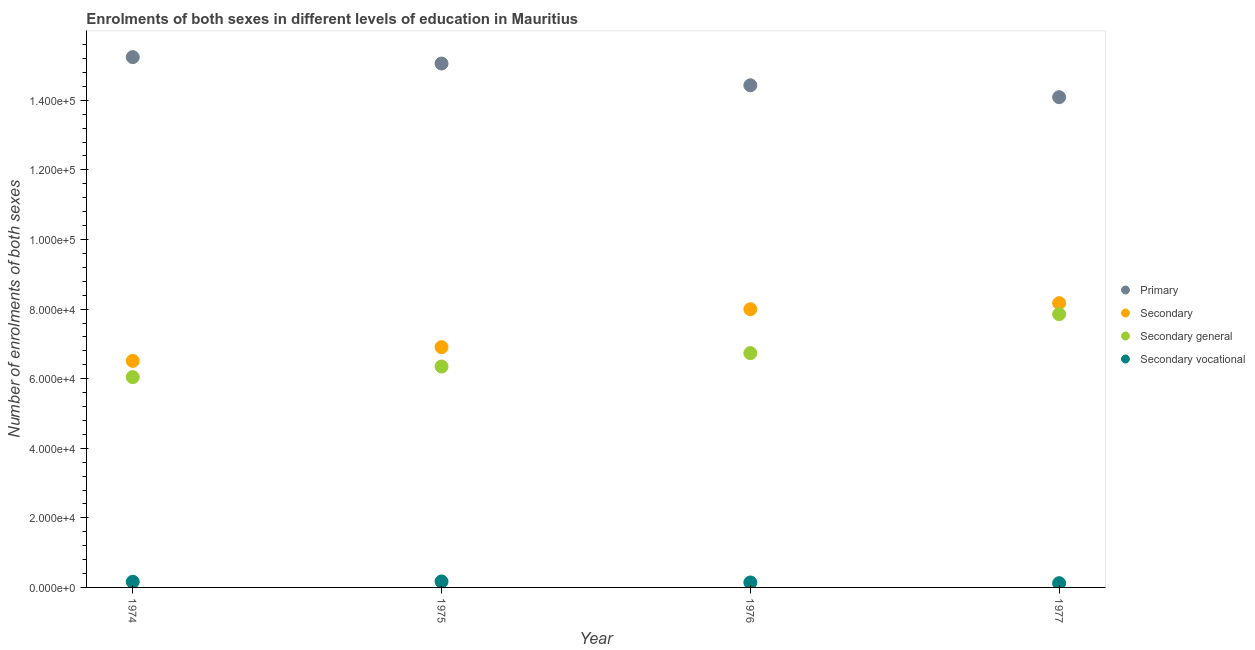What is the number of enrolments in secondary education in 1977?
Keep it short and to the point. 8.17e+04. Across all years, what is the maximum number of enrolments in secondary vocational education?
Make the answer very short. 1716. Across all years, what is the minimum number of enrolments in primary education?
Ensure brevity in your answer.  1.41e+05. In which year was the number of enrolments in primary education maximum?
Offer a very short reply. 1974. In which year was the number of enrolments in secondary general education minimum?
Your response must be concise. 1974. What is the total number of enrolments in secondary education in the graph?
Offer a very short reply. 2.96e+05. What is the difference between the number of enrolments in secondary education in 1974 and that in 1976?
Offer a very short reply. -1.48e+04. What is the difference between the number of enrolments in secondary general education in 1974 and the number of enrolments in secondary education in 1976?
Provide a short and direct response. -1.95e+04. What is the average number of enrolments in secondary vocational education per year?
Provide a succinct answer. 1495.25. In the year 1976, what is the difference between the number of enrolments in secondary general education and number of enrolments in secondary education?
Your answer should be compact. -1.26e+04. In how many years, is the number of enrolments in primary education greater than 124000?
Your answer should be very brief. 4. What is the ratio of the number of enrolments in primary education in 1976 to that in 1977?
Your response must be concise. 1.02. What is the difference between the highest and the second highest number of enrolments in secondary general education?
Your answer should be very brief. 1.12e+04. What is the difference between the highest and the lowest number of enrolments in primary education?
Your response must be concise. 1.15e+04. Is it the case that in every year, the sum of the number of enrolments in primary education and number of enrolments in secondary education is greater than the number of enrolments in secondary general education?
Your answer should be very brief. Yes. Does the number of enrolments in secondary general education monotonically increase over the years?
Provide a short and direct response. Yes. Does the graph contain any zero values?
Your answer should be very brief. No. Where does the legend appear in the graph?
Your answer should be very brief. Center right. What is the title of the graph?
Give a very brief answer. Enrolments of both sexes in different levels of education in Mauritius. What is the label or title of the Y-axis?
Offer a very short reply. Number of enrolments of both sexes. What is the Number of enrolments of both sexes of Primary in 1974?
Give a very brief answer. 1.52e+05. What is the Number of enrolments of both sexes of Secondary in 1974?
Offer a terse response. 6.51e+04. What is the Number of enrolments of both sexes of Secondary general in 1974?
Offer a terse response. 6.04e+04. What is the Number of enrolments of both sexes of Secondary vocational in 1974?
Make the answer very short. 1621. What is the Number of enrolments of both sexes in Primary in 1975?
Offer a very short reply. 1.51e+05. What is the Number of enrolments of both sexes of Secondary in 1975?
Offer a terse response. 6.91e+04. What is the Number of enrolments of both sexes of Secondary general in 1975?
Provide a succinct answer. 6.35e+04. What is the Number of enrolments of both sexes in Secondary vocational in 1975?
Make the answer very short. 1716. What is the Number of enrolments of both sexes of Primary in 1976?
Make the answer very short. 1.44e+05. What is the Number of enrolments of both sexes of Secondary in 1976?
Keep it short and to the point. 8.00e+04. What is the Number of enrolments of both sexes in Secondary general in 1976?
Provide a short and direct response. 6.73e+04. What is the Number of enrolments of both sexes of Secondary vocational in 1976?
Your response must be concise. 1423. What is the Number of enrolments of both sexes in Primary in 1977?
Keep it short and to the point. 1.41e+05. What is the Number of enrolments of both sexes in Secondary in 1977?
Your answer should be very brief. 8.17e+04. What is the Number of enrolments of both sexes of Secondary general in 1977?
Provide a short and direct response. 7.85e+04. What is the Number of enrolments of both sexes of Secondary vocational in 1977?
Keep it short and to the point. 1221. Across all years, what is the maximum Number of enrolments of both sexes of Primary?
Provide a succinct answer. 1.52e+05. Across all years, what is the maximum Number of enrolments of both sexes in Secondary?
Provide a succinct answer. 8.17e+04. Across all years, what is the maximum Number of enrolments of both sexes in Secondary general?
Your answer should be very brief. 7.85e+04. Across all years, what is the maximum Number of enrolments of both sexes in Secondary vocational?
Keep it short and to the point. 1716. Across all years, what is the minimum Number of enrolments of both sexes of Primary?
Your answer should be very brief. 1.41e+05. Across all years, what is the minimum Number of enrolments of both sexes in Secondary?
Provide a short and direct response. 6.51e+04. Across all years, what is the minimum Number of enrolments of both sexes in Secondary general?
Give a very brief answer. 6.04e+04. Across all years, what is the minimum Number of enrolments of both sexes of Secondary vocational?
Your answer should be compact. 1221. What is the total Number of enrolments of both sexes of Primary in the graph?
Your answer should be very brief. 5.88e+05. What is the total Number of enrolments of both sexes in Secondary in the graph?
Provide a succinct answer. 2.96e+05. What is the total Number of enrolments of both sexes of Secondary general in the graph?
Keep it short and to the point. 2.70e+05. What is the total Number of enrolments of both sexes in Secondary vocational in the graph?
Give a very brief answer. 5981. What is the difference between the Number of enrolments of both sexes of Primary in 1974 and that in 1975?
Your response must be concise. 1844. What is the difference between the Number of enrolments of both sexes in Secondary in 1974 and that in 1975?
Keep it short and to the point. -3948. What is the difference between the Number of enrolments of both sexes of Secondary general in 1974 and that in 1975?
Ensure brevity in your answer.  -3051. What is the difference between the Number of enrolments of both sexes of Secondary vocational in 1974 and that in 1975?
Offer a very short reply. -95. What is the difference between the Number of enrolments of both sexes of Primary in 1974 and that in 1976?
Offer a terse response. 8092. What is the difference between the Number of enrolments of both sexes in Secondary in 1974 and that in 1976?
Offer a very short reply. -1.48e+04. What is the difference between the Number of enrolments of both sexes in Secondary general in 1974 and that in 1976?
Your answer should be compact. -6904. What is the difference between the Number of enrolments of both sexes of Secondary vocational in 1974 and that in 1976?
Offer a very short reply. 198. What is the difference between the Number of enrolments of both sexes in Primary in 1974 and that in 1977?
Your response must be concise. 1.15e+04. What is the difference between the Number of enrolments of both sexes in Secondary in 1974 and that in 1977?
Offer a very short reply. -1.66e+04. What is the difference between the Number of enrolments of both sexes in Secondary general in 1974 and that in 1977?
Ensure brevity in your answer.  -1.81e+04. What is the difference between the Number of enrolments of both sexes in Secondary vocational in 1974 and that in 1977?
Make the answer very short. 400. What is the difference between the Number of enrolments of both sexes of Primary in 1975 and that in 1976?
Offer a very short reply. 6248. What is the difference between the Number of enrolments of both sexes in Secondary in 1975 and that in 1976?
Ensure brevity in your answer.  -1.09e+04. What is the difference between the Number of enrolments of both sexes of Secondary general in 1975 and that in 1976?
Your answer should be very brief. -3853. What is the difference between the Number of enrolments of both sexes in Secondary vocational in 1975 and that in 1976?
Provide a short and direct response. 293. What is the difference between the Number of enrolments of both sexes of Primary in 1975 and that in 1977?
Provide a short and direct response. 9668. What is the difference between the Number of enrolments of both sexes in Secondary in 1975 and that in 1977?
Keep it short and to the point. -1.26e+04. What is the difference between the Number of enrolments of both sexes of Secondary general in 1975 and that in 1977?
Provide a succinct answer. -1.50e+04. What is the difference between the Number of enrolments of both sexes in Secondary vocational in 1975 and that in 1977?
Give a very brief answer. 495. What is the difference between the Number of enrolments of both sexes in Primary in 1976 and that in 1977?
Make the answer very short. 3420. What is the difference between the Number of enrolments of both sexes in Secondary in 1976 and that in 1977?
Provide a short and direct response. -1739. What is the difference between the Number of enrolments of both sexes of Secondary general in 1976 and that in 1977?
Provide a succinct answer. -1.12e+04. What is the difference between the Number of enrolments of both sexes of Secondary vocational in 1976 and that in 1977?
Offer a very short reply. 202. What is the difference between the Number of enrolments of both sexes of Primary in 1974 and the Number of enrolments of both sexes of Secondary in 1975?
Offer a terse response. 8.34e+04. What is the difference between the Number of enrolments of both sexes of Primary in 1974 and the Number of enrolments of both sexes of Secondary general in 1975?
Provide a succinct answer. 8.89e+04. What is the difference between the Number of enrolments of both sexes in Primary in 1974 and the Number of enrolments of both sexes in Secondary vocational in 1975?
Ensure brevity in your answer.  1.51e+05. What is the difference between the Number of enrolments of both sexes of Secondary in 1974 and the Number of enrolments of both sexes of Secondary general in 1975?
Provide a succinct answer. 1621. What is the difference between the Number of enrolments of both sexes of Secondary in 1974 and the Number of enrolments of both sexes of Secondary vocational in 1975?
Provide a short and direct response. 6.34e+04. What is the difference between the Number of enrolments of both sexes in Secondary general in 1974 and the Number of enrolments of both sexes in Secondary vocational in 1975?
Provide a short and direct response. 5.87e+04. What is the difference between the Number of enrolments of both sexes of Primary in 1974 and the Number of enrolments of both sexes of Secondary in 1976?
Provide a succinct answer. 7.25e+04. What is the difference between the Number of enrolments of both sexes of Primary in 1974 and the Number of enrolments of both sexes of Secondary general in 1976?
Offer a terse response. 8.51e+04. What is the difference between the Number of enrolments of both sexes of Primary in 1974 and the Number of enrolments of both sexes of Secondary vocational in 1976?
Keep it short and to the point. 1.51e+05. What is the difference between the Number of enrolments of both sexes of Secondary in 1974 and the Number of enrolments of both sexes of Secondary general in 1976?
Give a very brief answer. -2232. What is the difference between the Number of enrolments of both sexes in Secondary in 1974 and the Number of enrolments of both sexes in Secondary vocational in 1976?
Offer a terse response. 6.37e+04. What is the difference between the Number of enrolments of both sexes in Secondary general in 1974 and the Number of enrolments of both sexes in Secondary vocational in 1976?
Keep it short and to the point. 5.90e+04. What is the difference between the Number of enrolments of both sexes in Primary in 1974 and the Number of enrolments of both sexes in Secondary in 1977?
Make the answer very short. 7.07e+04. What is the difference between the Number of enrolments of both sexes in Primary in 1974 and the Number of enrolments of both sexes in Secondary general in 1977?
Your response must be concise. 7.39e+04. What is the difference between the Number of enrolments of both sexes of Primary in 1974 and the Number of enrolments of both sexes of Secondary vocational in 1977?
Ensure brevity in your answer.  1.51e+05. What is the difference between the Number of enrolments of both sexes of Secondary in 1974 and the Number of enrolments of both sexes of Secondary general in 1977?
Keep it short and to the point. -1.34e+04. What is the difference between the Number of enrolments of both sexes of Secondary in 1974 and the Number of enrolments of both sexes of Secondary vocational in 1977?
Provide a short and direct response. 6.39e+04. What is the difference between the Number of enrolments of both sexes of Secondary general in 1974 and the Number of enrolments of both sexes of Secondary vocational in 1977?
Provide a short and direct response. 5.92e+04. What is the difference between the Number of enrolments of both sexes of Primary in 1975 and the Number of enrolments of both sexes of Secondary in 1976?
Provide a short and direct response. 7.06e+04. What is the difference between the Number of enrolments of both sexes of Primary in 1975 and the Number of enrolments of both sexes of Secondary general in 1976?
Provide a short and direct response. 8.32e+04. What is the difference between the Number of enrolments of both sexes of Primary in 1975 and the Number of enrolments of both sexes of Secondary vocational in 1976?
Keep it short and to the point. 1.49e+05. What is the difference between the Number of enrolments of both sexes in Secondary in 1975 and the Number of enrolments of both sexes in Secondary general in 1976?
Your response must be concise. 1716. What is the difference between the Number of enrolments of both sexes of Secondary in 1975 and the Number of enrolments of both sexes of Secondary vocational in 1976?
Offer a very short reply. 6.76e+04. What is the difference between the Number of enrolments of both sexes of Secondary general in 1975 and the Number of enrolments of both sexes of Secondary vocational in 1976?
Your response must be concise. 6.21e+04. What is the difference between the Number of enrolments of both sexes of Primary in 1975 and the Number of enrolments of both sexes of Secondary in 1977?
Your answer should be very brief. 6.89e+04. What is the difference between the Number of enrolments of both sexes in Primary in 1975 and the Number of enrolments of both sexes in Secondary general in 1977?
Keep it short and to the point. 7.20e+04. What is the difference between the Number of enrolments of both sexes of Primary in 1975 and the Number of enrolments of both sexes of Secondary vocational in 1977?
Give a very brief answer. 1.49e+05. What is the difference between the Number of enrolments of both sexes of Secondary in 1975 and the Number of enrolments of both sexes of Secondary general in 1977?
Give a very brief answer. -9477. What is the difference between the Number of enrolments of both sexes of Secondary in 1975 and the Number of enrolments of both sexes of Secondary vocational in 1977?
Your response must be concise. 6.78e+04. What is the difference between the Number of enrolments of both sexes in Secondary general in 1975 and the Number of enrolments of both sexes in Secondary vocational in 1977?
Your response must be concise. 6.23e+04. What is the difference between the Number of enrolments of both sexes of Primary in 1976 and the Number of enrolments of both sexes of Secondary in 1977?
Provide a short and direct response. 6.26e+04. What is the difference between the Number of enrolments of both sexes in Primary in 1976 and the Number of enrolments of both sexes in Secondary general in 1977?
Your response must be concise. 6.58e+04. What is the difference between the Number of enrolments of both sexes of Primary in 1976 and the Number of enrolments of both sexes of Secondary vocational in 1977?
Your answer should be compact. 1.43e+05. What is the difference between the Number of enrolments of both sexes of Secondary in 1976 and the Number of enrolments of both sexes of Secondary general in 1977?
Make the answer very short. 1423. What is the difference between the Number of enrolments of both sexes in Secondary in 1976 and the Number of enrolments of both sexes in Secondary vocational in 1977?
Your answer should be very brief. 7.87e+04. What is the difference between the Number of enrolments of both sexes in Secondary general in 1976 and the Number of enrolments of both sexes in Secondary vocational in 1977?
Offer a very short reply. 6.61e+04. What is the average Number of enrolments of both sexes of Primary per year?
Your response must be concise. 1.47e+05. What is the average Number of enrolments of both sexes in Secondary per year?
Your answer should be compact. 7.40e+04. What is the average Number of enrolments of both sexes of Secondary general per year?
Offer a terse response. 6.75e+04. What is the average Number of enrolments of both sexes in Secondary vocational per year?
Offer a terse response. 1495.25. In the year 1974, what is the difference between the Number of enrolments of both sexes of Primary and Number of enrolments of both sexes of Secondary?
Ensure brevity in your answer.  8.73e+04. In the year 1974, what is the difference between the Number of enrolments of both sexes of Primary and Number of enrolments of both sexes of Secondary general?
Give a very brief answer. 9.20e+04. In the year 1974, what is the difference between the Number of enrolments of both sexes of Primary and Number of enrolments of both sexes of Secondary vocational?
Your response must be concise. 1.51e+05. In the year 1974, what is the difference between the Number of enrolments of both sexes of Secondary and Number of enrolments of both sexes of Secondary general?
Your response must be concise. 4672. In the year 1974, what is the difference between the Number of enrolments of both sexes of Secondary and Number of enrolments of both sexes of Secondary vocational?
Your response must be concise. 6.35e+04. In the year 1974, what is the difference between the Number of enrolments of both sexes in Secondary general and Number of enrolments of both sexes in Secondary vocational?
Provide a short and direct response. 5.88e+04. In the year 1975, what is the difference between the Number of enrolments of both sexes of Primary and Number of enrolments of both sexes of Secondary?
Offer a very short reply. 8.15e+04. In the year 1975, what is the difference between the Number of enrolments of both sexes of Primary and Number of enrolments of both sexes of Secondary general?
Make the answer very short. 8.71e+04. In the year 1975, what is the difference between the Number of enrolments of both sexes of Primary and Number of enrolments of both sexes of Secondary vocational?
Offer a very short reply. 1.49e+05. In the year 1975, what is the difference between the Number of enrolments of both sexes in Secondary and Number of enrolments of both sexes in Secondary general?
Provide a succinct answer. 5569. In the year 1975, what is the difference between the Number of enrolments of both sexes in Secondary and Number of enrolments of both sexes in Secondary vocational?
Keep it short and to the point. 6.73e+04. In the year 1975, what is the difference between the Number of enrolments of both sexes in Secondary general and Number of enrolments of both sexes in Secondary vocational?
Your response must be concise. 6.18e+04. In the year 1976, what is the difference between the Number of enrolments of both sexes of Primary and Number of enrolments of both sexes of Secondary?
Make the answer very short. 6.44e+04. In the year 1976, what is the difference between the Number of enrolments of both sexes in Primary and Number of enrolments of both sexes in Secondary general?
Your response must be concise. 7.70e+04. In the year 1976, what is the difference between the Number of enrolments of both sexes in Primary and Number of enrolments of both sexes in Secondary vocational?
Offer a very short reply. 1.43e+05. In the year 1976, what is the difference between the Number of enrolments of both sexes of Secondary and Number of enrolments of both sexes of Secondary general?
Give a very brief answer. 1.26e+04. In the year 1976, what is the difference between the Number of enrolments of both sexes of Secondary and Number of enrolments of both sexes of Secondary vocational?
Your answer should be compact. 7.85e+04. In the year 1976, what is the difference between the Number of enrolments of both sexes of Secondary general and Number of enrolments of both sexes of Secondary vocational?
Your answer should be compact. 6.59e+04. In the year 1977, what is the difference between the Number of enrolments of both sexes in Primary and Number of enrolments of both sexes in Secondary?
Offer a very short reply. 5.92e+04. In the year 1977, what is the difference between the Number of enrolments of both sexes in Primary and Number of enrolments of both sexes in Secondary general?
Provide a short and direct response. 6.24e+04. In the year 1977, what is the difference between the Number of enrolments of both sexes of Primary and Number of enrolments of both sexes of Secondary vocational?
Offer a terse response. 1.40e+05. In the year 1977, what is the difference between the Number of enrolments of both sexes of Secondary and Number of enrolments of both sexes of Secondary general?
Make the answer very short. 3162. In the year 1977, what is the difference between the Number of enrolments of both sexes of Secondary and Number of enrolments of both sexes of Secondary vocational?
Your answer should be very brief. 8.05e+04. In the year 1977, what is the difference between the Number of enrolments of both sexes of Secondary general and Number of enrolments of both sexes of Secondary vocational?
Provide a succinct answer. 7.73e+04. What is the ratio of the Number of enrolments of both sexes in Primary in 1974 to that in 1975?
Give a very brief answer. 1.01. What is the ratio of the Number of enrolments of both sexes of Secondary in 1974 to that in 1975?
Provide a succinct answer. 0.94. What is the ratio of the Number of enrolments of both sexes in Secondary general in 1974 to that in 1975?
Keep it short and to the point. 0.95. What is the ratio of the Number of enrolments of both sexes of Secondary vocational in 1974 to that in 1975?
Make the answer very short. 0.94. What is the ratio of the Number of enrolments of both sexes of Primary in 1974 to that in 1976?
Make the answer very short. 1.06. What is the ratio of the Number of enrolments of both sexes of Secondary in 1974 to that in 1976?
Give a very brief answer. 0.81. What is the ratio of the Number of enrolments of both sexes in Secondary general in 1974 to that in 1976?
Your response must be concise. 0.9. What is the ratio of the Number of enrolments of both sexes of Secondary vocational in 1974 to that in 1976?
Keep it short and to the point. 1.14. What is the ratio of the Number of enrolments of both sexes in Primary in 1974 to that in 1977?
Provide a succinct answer. 1.08. What is the ratio of the Number of enrolments of both sexes in Secondary in 1974 to that in 1977?
Make the answer very short. 0.8. What is the ratio of the Number of enrolments of both sexes in Secondary general in 1974 to that in 1977?
Your answer should be very brief. 0.77. What is the ratio of the Number of enrolments of both sexes of Secondary vocational in 1974 to that in 1977?
Offer a very short reply. 1.33. What is the ratio of the Number of enrolments of both sexes in Primary in 1975 to that in 1976?
Provide a succinct answer. 1.04. What is the ratio of the Number of enrolments of both sexes of Secondary in 1975 to that in 1976?
Keep it short and to the point. 0.86. What is the ratio of the Number of enrolments of both sexes of Secondary general in 1975 to that in 1976?
Give a very brief answer. 0.94. What is the ratio of the Number of enrolments of both sexes in Secondary vocational in 1975 to that in 1976?
Provide a succinct answer. 1.21. What is the ratio of the Number of enrolments of both sexes of Primary in 1975 to that in 1977?
Make the answer very short. 1.07. What is the ratio of the Number of enrolments of both sexes in Secondary in 1975 to that in 1977?
Provide a short and direct response. 0.85. What is the ratio of the Number of enrolments of both sexes in Secondary general in 1975 to that in 1977?
Provide a succinct answer. 0.81. What is the ratio of the Number of enrolments of both sexes of Secondary vocational in 1975 to that in 1977?
Provide a short and direct response. 1.41. What is the ratio of the Number of enrolments of both sexes in Primary in 1976 to that in 1977?
Make the answer very short. 1.02. What is the ratio of the Number of enrolments of both sexes in Secondary in 1976 to that in 1977?
Offer a terse response. 0.98. What is the ratio of the Number of enrolments of both sexes of Secondary general in 1976 to that in 1977?
Provide a short and direct response. 0.86. What is the ratio of the Number of enrolments of both sexes in Secondary vocational in 1976 to that in 1977?
Ensure brevity in your answer.  1.17. What is the difference between the highest and the second highest Number of enrolments of both sexes of Primary?
Give a very brief answer. 1844. What is the difference between the highest and the second highest Number of enrolments of both sexes in Secondary?
Offer a very short reply. 1739. What is the difference between the highest and the second highest Number of enrolments of both sexes in Secondary general?
Make the answer very short. 1.12e+04. What is the difference between the highest and the lowest Number of enrolments of both sexes of Primary?
Ensure brevity in your answer.  1.15e+04. What is the difference between the highest and the lowest Number of enrolments of both sexes of Secondary?
Keep it short and to the point. 1.66e+04. What is the difference between the highest and the lowest Number of enrolments of both sexes in Secondary general?
Your answer should be compact. 1.81e+04. What is the difference between the highest and the lowest Number of enrolments of both sexes in Secondary vocational?
Keep it short and to the point. 495. 